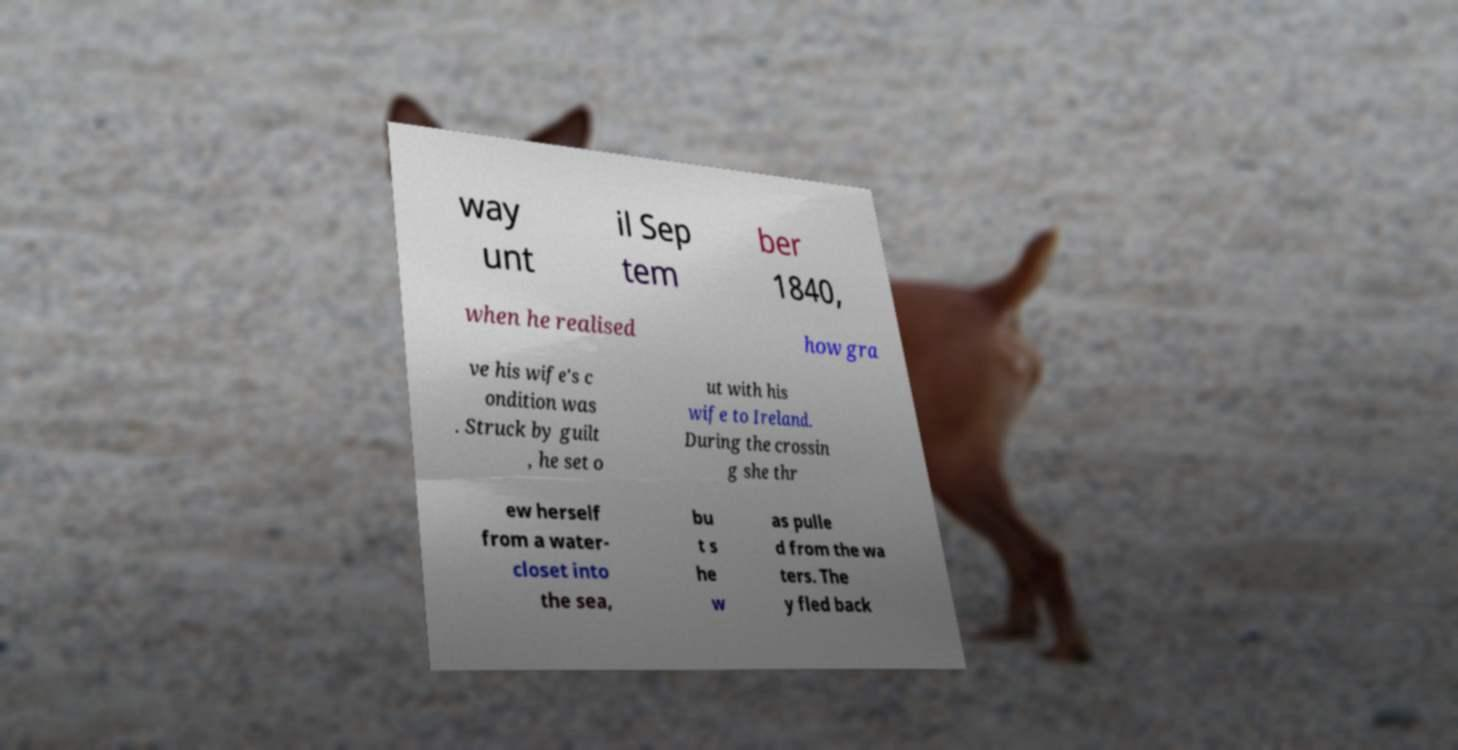For documentation purposes, I need the text within this image transcribed. Could you provide that? way unt il Sep tem ber 1840, when he realised how gra ve his wife's c ondition was . Struck by guilt , he set o ut with his wife to Ireland. During the crossin g she thr ew herself from a water- closet into the sea, bu t s he w as pulle d from the wa ters. The y fled back 